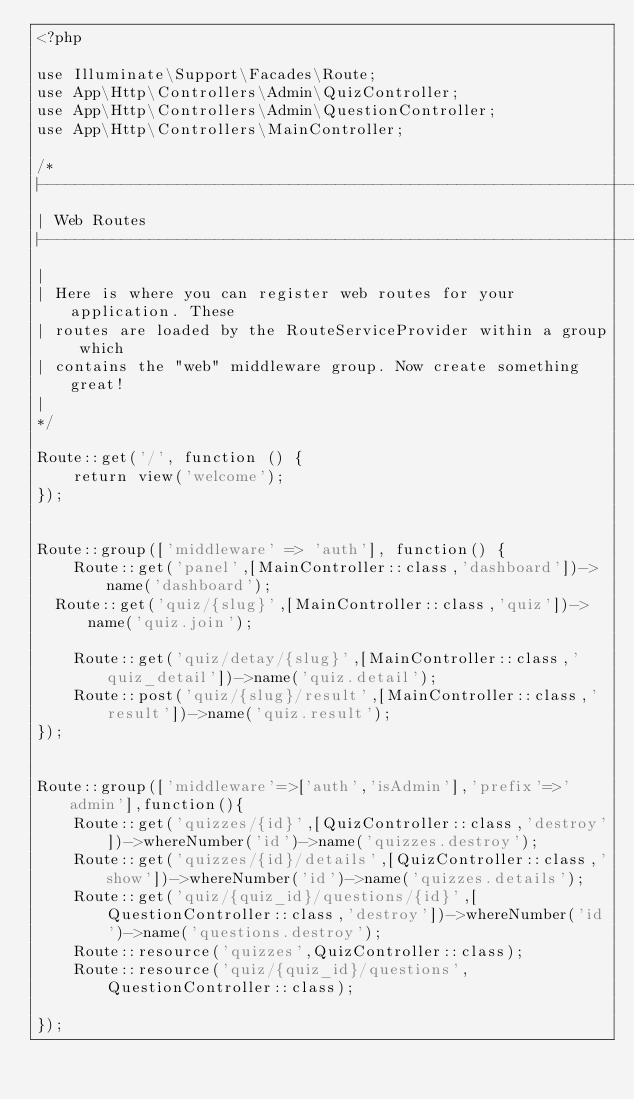<code> <loc_0><loc_0><loc_500><loc_500><_PHP_><?php

use Illuminate\Support\Facades\Route;
use App\Http\Controllers\Admin\QuizController;
use App\Http\Controllers\Admin\QuestionController;
use App\Http\Controllers\MainController;

/*
|--------------------------------------------------------------------------
| Web Routes
|--------------------------------------------------------------------------
| 
| Here is where you can register web routes for your application. These
| routes are loaded by the RouteServiceProvider within a group which
| contains the "web" middleware group. Now create something great!
| 
*/ 
 
Route::get('/', function () {
    return view('welcome'); 
});


Route::group(['middleware' => 'auth'], function() {
    Route::get('panel',[MainController::class,'dashboard'])->name('dashboard');
	Route::get('quiz/{slug}',[MainController::class,'quiz'])->name('quiz.join');
  
    Route::get('quiz/detay/{slug}',[MainController::class,'quiz_detail'])->name('quiz.detail');
    Route::post('quiz/{slug}/result',[MainController::class,'result'])->name('quiz.result');
});
 

Route::group(['middleware'=>['auth','isAdmin'],'prefix'=>'admin'],function(){
    Route::get('quizzes/{id}',[QuizController::class,'destroy'])->whereNumber('id')->name('quizzes.destroy');
    Route::get('quizzes/{id}/details',[QuizController::class,'show'])->whereNumber('id')->name('quizzes.details');
    Route::get('quiz/{quiz_id}/questions/{id}',[QuestionController::class,'destroy'])->whereNumber('id')->name('questions.destroy');
    Route::resource('quizzes',QuizController::class);
    Route::resource('quiz/{quiz_id}/questions',QuestionController::class);

});</code> 